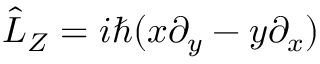<formula> <loc_0><loc_0><loc_500><loc_500>\hat { L } _ { Z } = i \hbar { ( } x \partial _ { y } - y \partial _ { x } )</formula> 